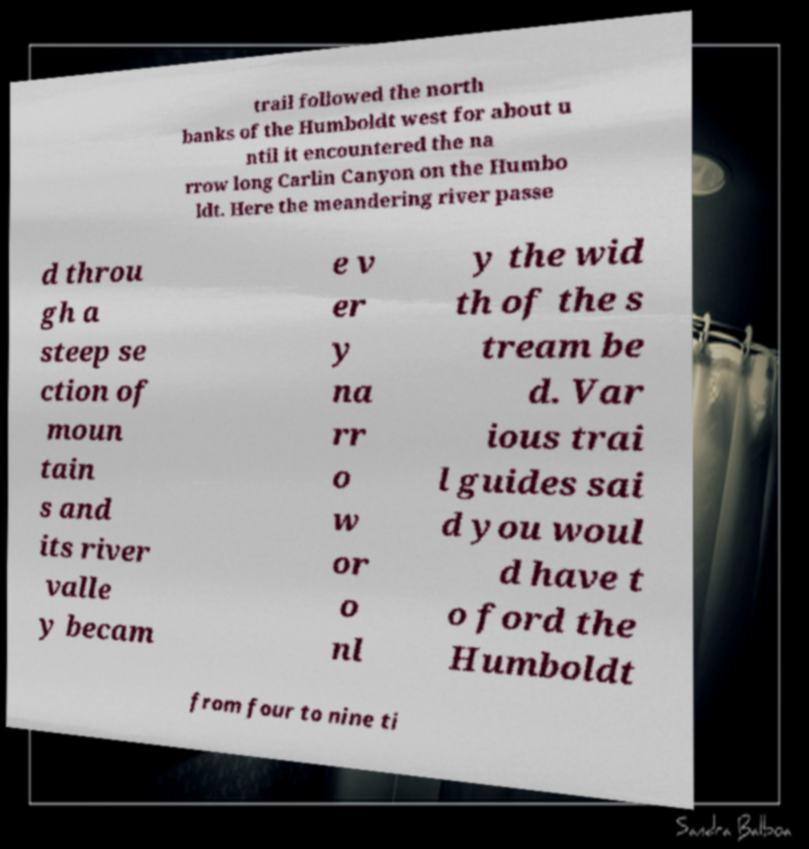For documentation purposes, I need the text within this image transcribed. Could you provide that? trail followed the north banks of the Humboldt west for about u ntil it encountered the na rrow long Carlin Canyon on the Humbo ldt. Here the meandering river passe d throu gh a steep se ction of moun tain s and its river valle y becam e v er y na rr o w or o nl y the wid th of the s tream be d. Var ious trai l guides sai d you woul d have t o ford the Humboldt from four to nine ti 